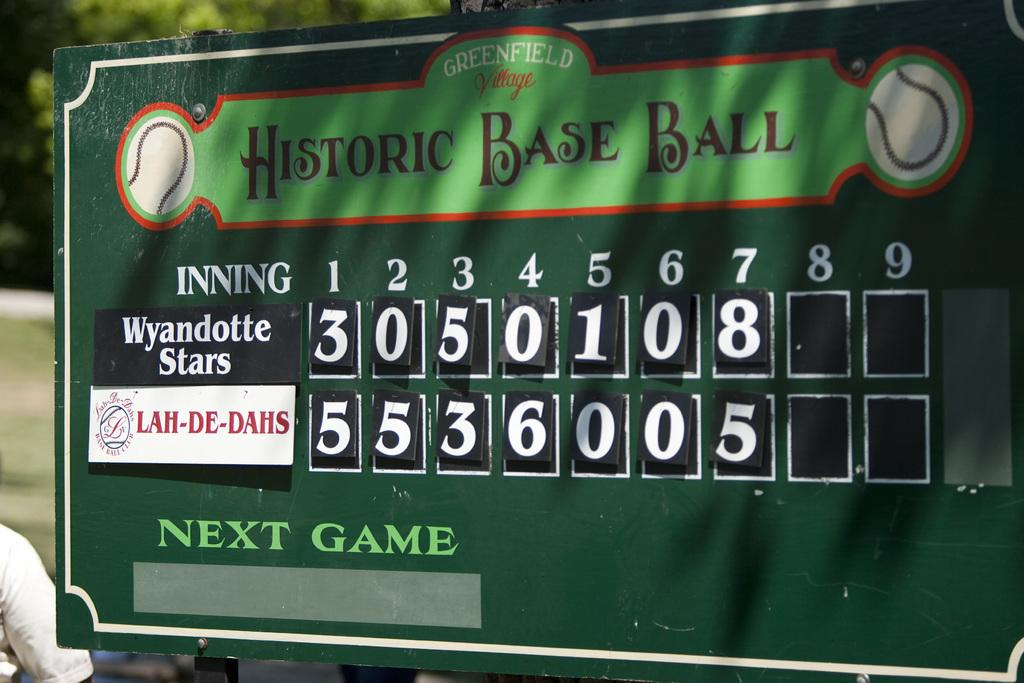<image>
Create a compact narrative representing the image presented. A ballpark scoreboard is keeping track of the game between the Wyandotte Stars and the Lah-De-Dahs. 